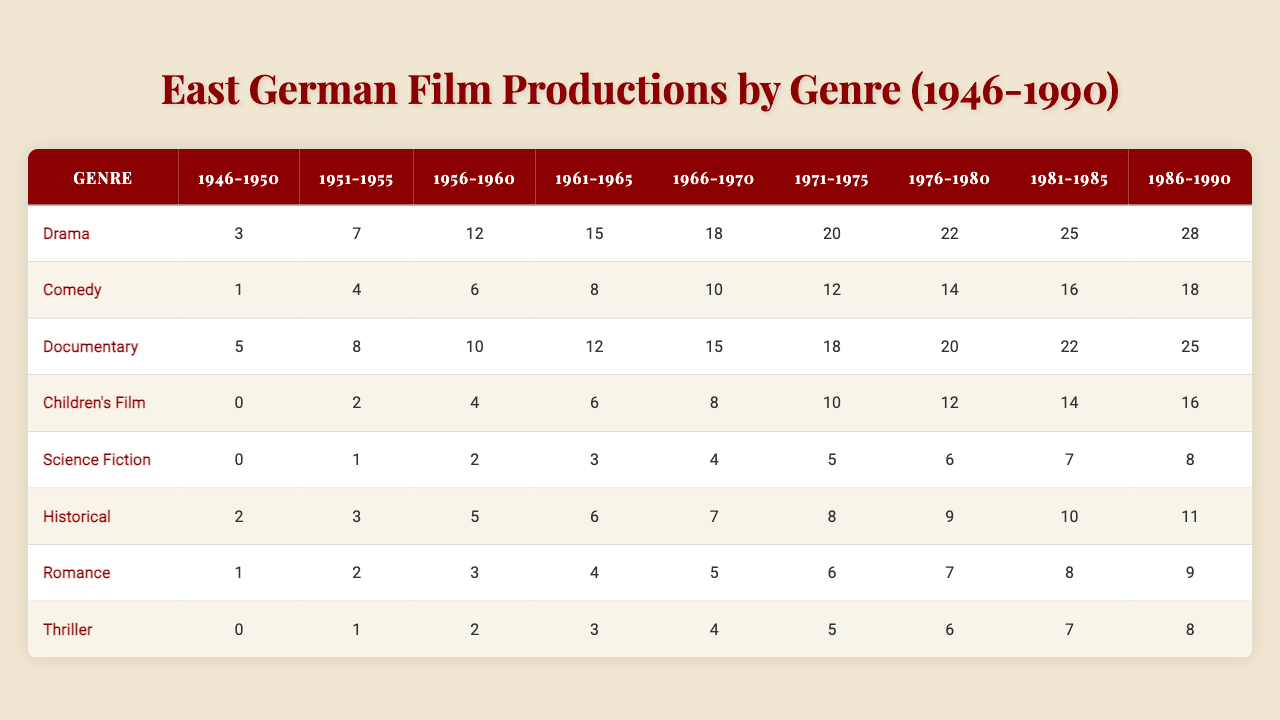What genre had the highest number of films produced in the 1986-1990 period? By looking at the table, we can examine the last column for the 1986-1990 period, which shows the following counts: Drama (28), Comedy (18), Documentary (25), Children's Film (16), Science Fiction (8), Historical (11), Romance (9), Thriller (8). The genre with the highest count is Drama, with 28 films.
Answer: Drama How many Children's Films were produced from 1971 to 1975? The values for Children's Films from 1971-1975 are 10, 12, 14, and 16 respectively. Summing these gives us 10 + 12 + 14 + 16 = 52.
Answer: 52 Which genre consistently had the least number of films produced from 1946 to 1990? Looking at the table across all years, the genre with the consistently lowest values is Science Fiction, with counts of 0 from 1946-1950, 1 from 1951-1955, and gradually increasing to 8 in 1986-1990, but it started the lowest and stayed lower than others for many periods.
Answer: Science Fiction What is the total number of Thriller films produced between 1961 and 1980? To find the total for Thriller, we need to add the values from the periods 1961-1965, 1966-1970, 1971-1975, and 1976-1980 which are 3, 4, 5, 6. So, the sum is 3 + 4 + 5 + 6 = 18.
Answer: 18 Was there a year range where no Children's Films were produced? Looking at the data, the count for Children's Films in the 1946-1950 period is 0. Therefore, there was indeed a time frame with no films produced in this genre.
Answer: Yes What is the average number of Drama films produced over all periods? First, we add the number of Drama films across all periods: 3 + 7 + 12 + 15 + 18 + 20 + 22 + 25 + 28 = 130. There are 9 periods, so the average is 130 / 9 ≈ 14.44.
Answer: Approximately 14.44 Which genre saw the highest increase in film production from the 1951-1955 period to the 1981-1985 period? We compare the counts for each genre in both periods. For drama: 7 to 25 (18 increase), Comedy: 4 to 16 (12 increase), Documentary: 8 to 22 (14 increase), and so forth. The highest increase is seen in Drama with an increase of 18 films.
Answer: Drama How many more documentaries were produced than thrillers in the 1976-1980 period? In the 1976-1980 period, 20 documentaries were produced, and 6 thrillers. The difference is 20 - 6 = 14.
Answer: 14 What was the trend of Historical films produced throughout the decades? If we list the production of Historical films over the decades: 2 (1946-1950), 3 (1951-1955), 5 (1956-1960), 6 (1961-1965), 7 (1966-1970), 8 (1971-1975), 9 (1976-1980), 10 (1981-1985), and 11 (1986-1990), it shows a consistent increase across all decades, demonstrating a positive trend.
Answer: Consistently increasing Which decade had the highest total film production across all genres? To find this, we must sum the total films produced in each decade: for 1946-1950: 11, 1951-1955: 25, 1956-1960: 47, 1961-1965: 48, 1966-1970: 55, 1971-1975: 81, 1976-1980: 88, 1981-1985: 104, and 1986-1990: 96. The highest total was in the decade of 1981-1985, with 104 films.
Answer: 1981-1985 